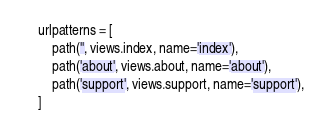<code> <loc_0><loc_0><loc_500><loc_500><_Python_>urlpatterns = [
    path('', views.index, name='index'),
    path('about', views.about, name='about'),
    path('support', views.support, name='support'),
]</code> 